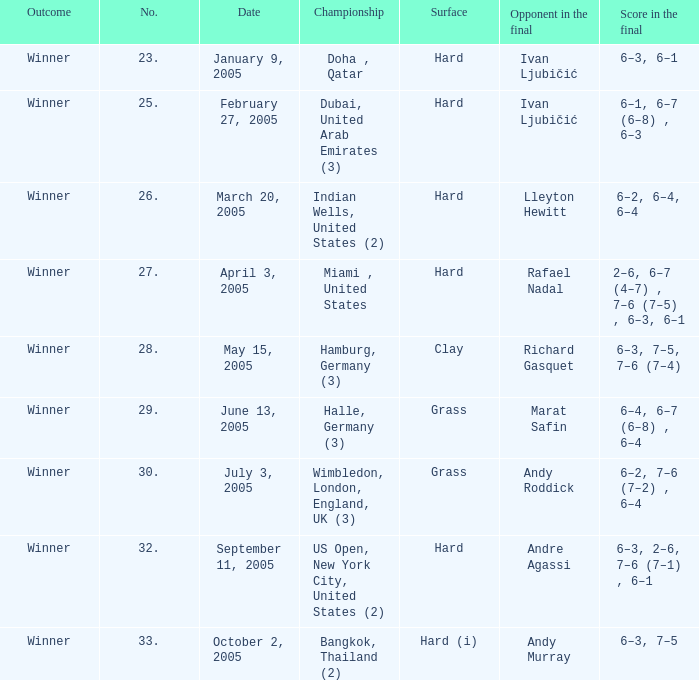In the championship Miami , United States, what is the score in the final? 2–6, 6–7 (4–7) , 7–6 (7–5) , 6–3, 6–1. 